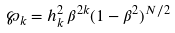<formula> <loc_0><loc_0><loc_500><loc_500>\wp _ { k } = h _ { k } ^ { 2 } \, \beta ^ { 2 k } ( 1 - \beta ^ { 2 } ) ^ { N / 2 }</formula> 